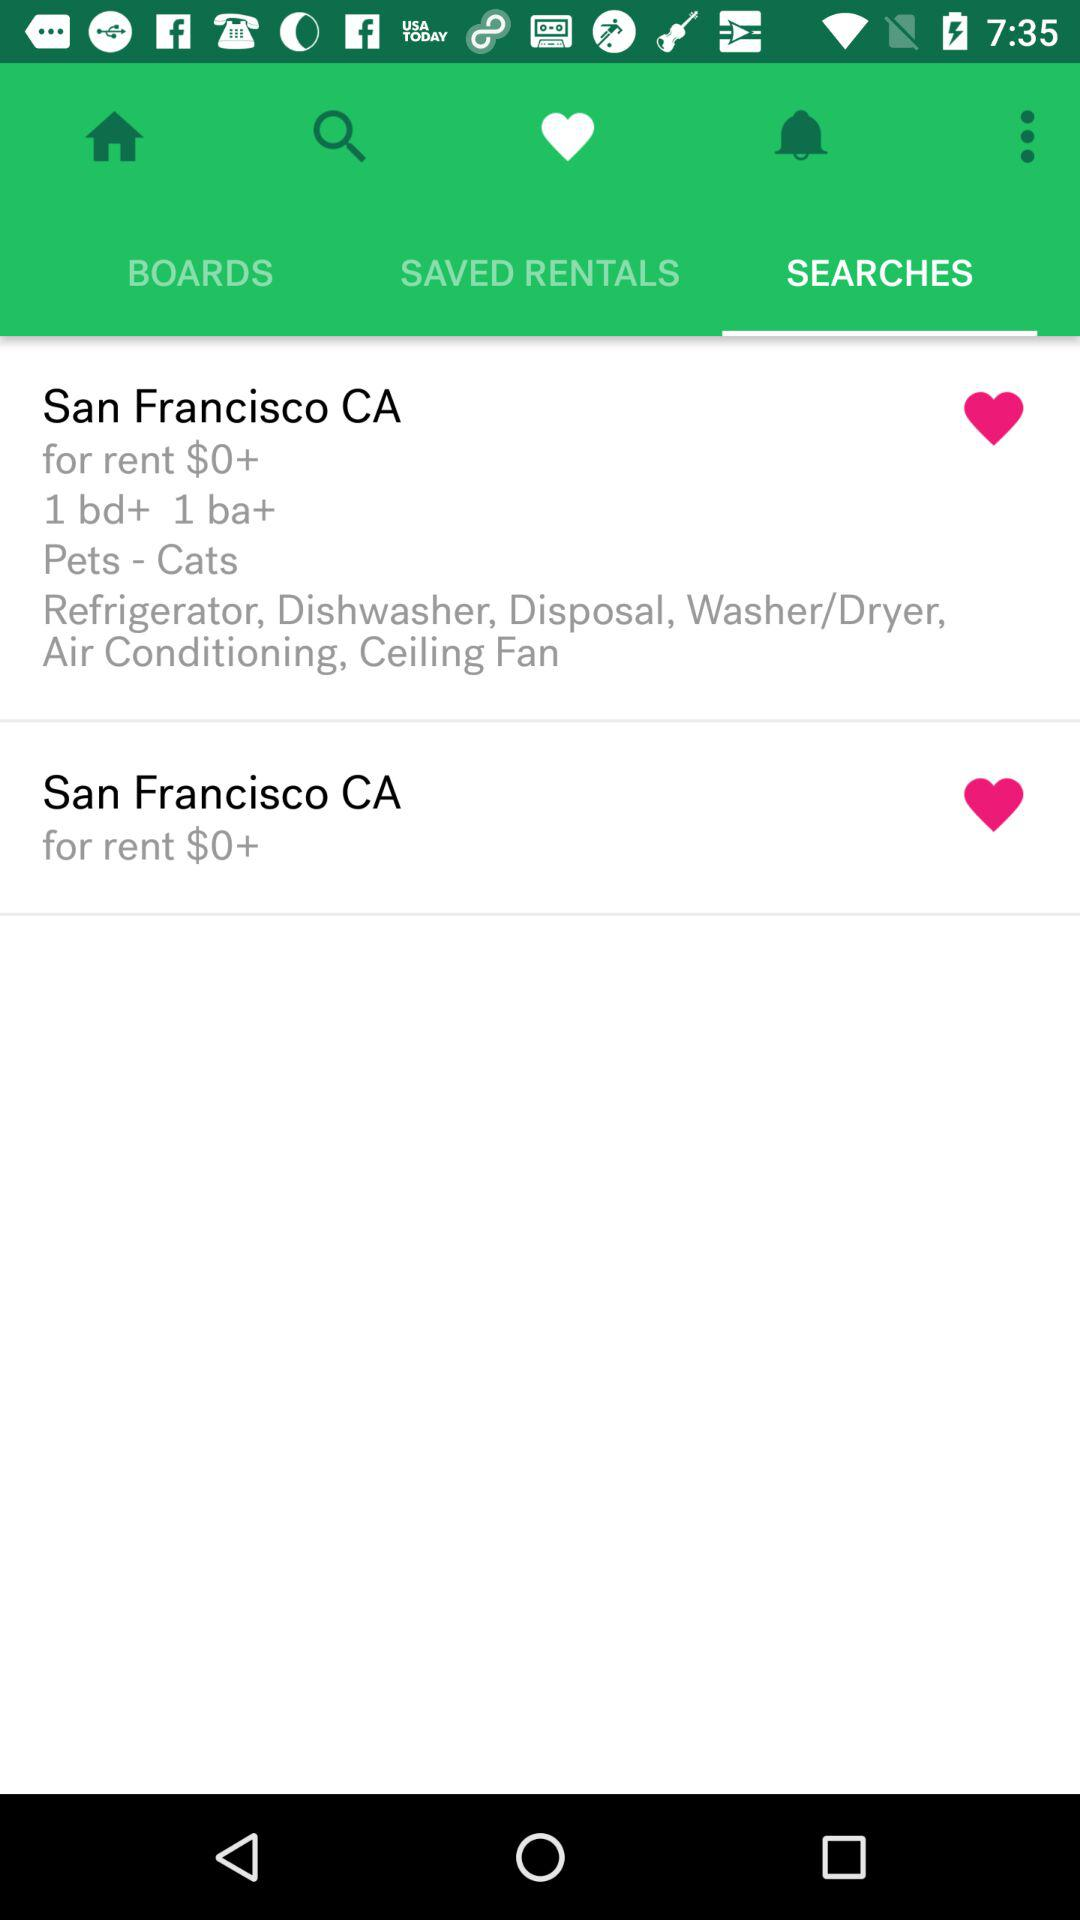What is the rent in San Francisco CA? The rent in San Francisco CA is $0+. 